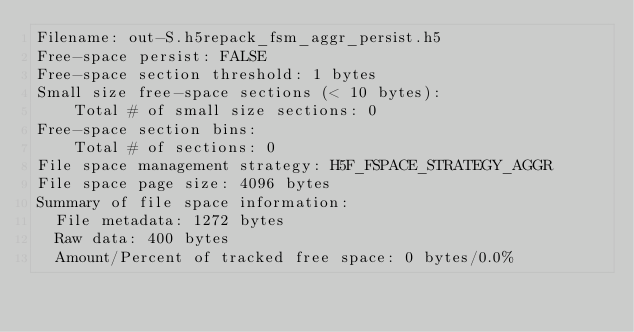<code> <loc_0><loc_0><loc_500><loc_500><_SQL_>Filename: out-S.h5repack_fsm_aggr_persist.h5
Free-space persist: FALSE
Free-space section threshold: 1 bytes
Small size free-space sections (< 10 bytes):
	Total # of small size sections: 0
Free-space section bins:
	Total # of sections: 0
File space management strategy: H5F_FSPACE_STRATEGY_AGGR
File space page size: 4096 bytes
Summary of file space information:
  File metadata: 1272 bytes
  Raw data: 400 bytes
  Amount/Percent of tracked free space: 0 bytes/0.0%</code> 